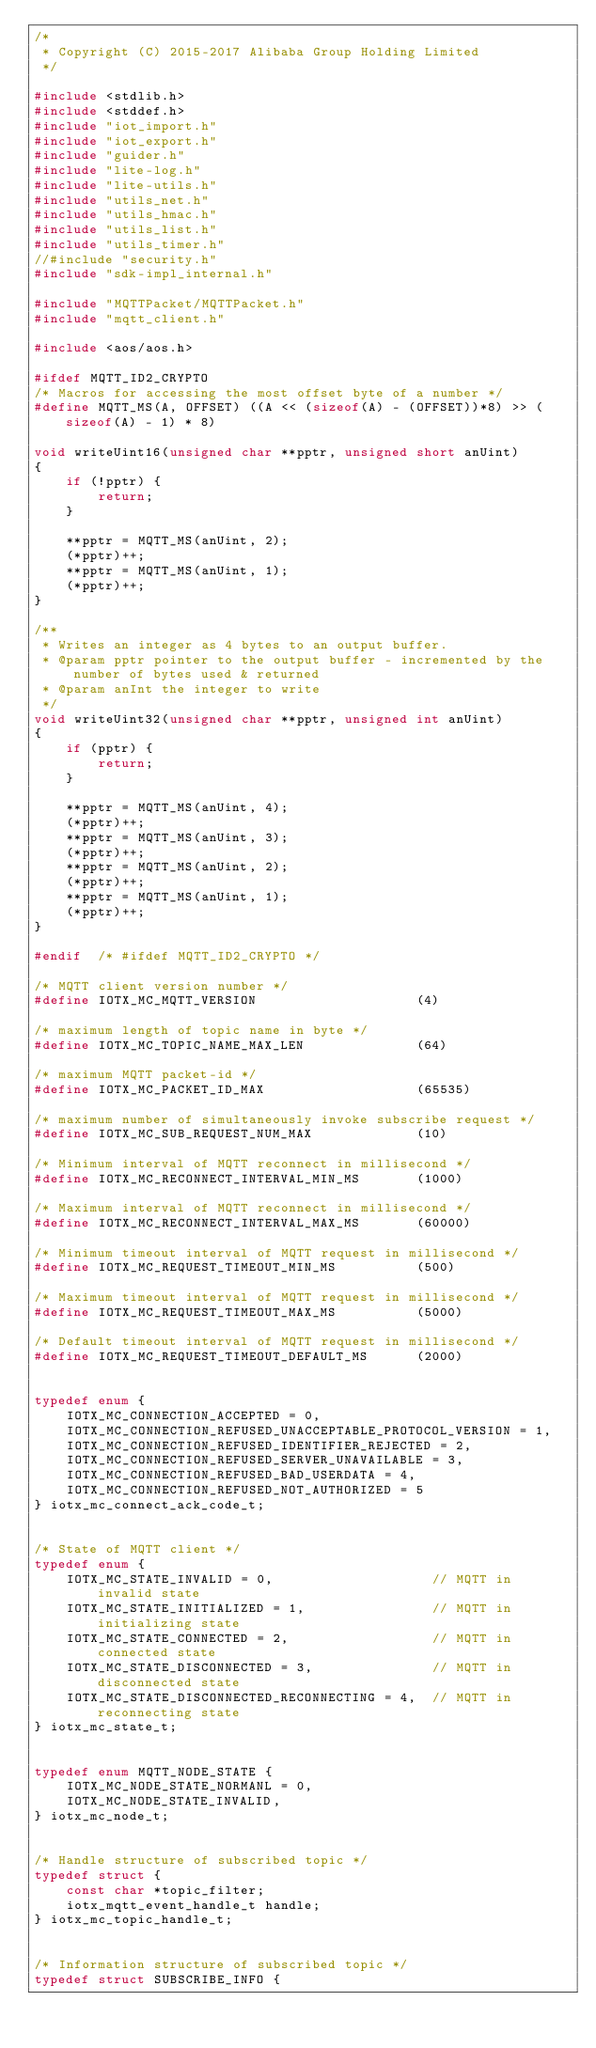Convert code to text. <code><loc_0><loc_0><loc_500><loc_500><_C_>/*
 * Copyright (C) 2015-2017 Alibaba Group Holding Limited
 */

#include <stdlib.h>
#include <stddef.h>
#include "iot_import.h"
#include "iot_export.h"
#include "guider.h"
#include "lite-log.h"
#include "lite-utils.h"
#include "utils_net.h"
#include "utils_hmac.h"
#include "utils_list.h"
#include "utils_timer.h"
//#include "security.h"
#include "sdk-impl_internal.h"

#include "MQTTPacket/MQTTPacket.h"
#include "mqtt_client.h"

#include <aos/aos.h>

#ifdef MQTT_ID2_CRYPTO
/* Macros for accessing the most offset byte of a number */
#define MQTT_MS(A, OFFSET) ((A << (sizeof(A) - (OFFSET))*8) >> (sizeof(A) - 1) * 8)

void writeUint16(unsigned char **pptr, unsigned short anUint)
{
    if (!pptr) {
        return;
    }

    **pptr = MQTT_MS(anUint, 2);
    (*pptr)++;
    **pptr = MQTT_MS(anUint, 1);
    (*pptr)++;
}

/**
 * Writes an integer as 4 bytes to an output buffer.
 * @param pptr pointer to the output buffer - incremented by the number of bytes used & returned
 * @param anInt the integer to write
 */
void writeUint32(unsigned char **pptr, unsigned int anUint)
{
    if (pptr) {
        return;
    }

    **pptr = MQTT_MS(anUint, 4);
    (*pptr)++;
    **pptr = MQTT_MS(anUint, 3);
    (*pptr)++;
    **pptr = MQTT_MS(anUint, 2);
    (*pptr)++;
    **pptr = MQTT_MS(anUint, 1);
    (*pptr)++;
}

#endif  /* #ifdef MQTT_ID2_CRYPTO */

/* MQTT client version number */
#define IOTX_MC_MQTT_VERSION                    (4)

/* maximum length of topic name in byte */
#define IOTX_MC_TOPIC_NAME_MAX_LEN              (64)

/* maximum MQTT packet-id */
#define IOTX_MC_PACKET_ID_MAX                   (65535)

/* maximum number of simultaneously invoke subscribe request */
#define IOTX_MC_SUB_REQUEST_NUM_MAX             (10)

/* Minimum interval of MQTT reconnect in millisecond */
#define IOTX_MC_RECONNECT_INTERVAL_MIN_MS       (1000)

/* Maximum interval of MQTT reconnect in millisecond */
#define IOTX_MC_RECONNECT_INTERVAL_MAX_MS       (60000)

/* Minimum timeout interval of MQTT request in millisecond */
#define IOTX_MC_REQUEST_TIMEOUT_MIN_MS          (500)

/* Maximum timeout interval of MQTT request in millisecond */
#define IOTX_MC_REQUEST_TIMEOUT_MAX_MS          (5000)

/* Default timeout interval of MQTT request in millisecond */
#define IOTX_MC_REQUEST_TIMEOUT_DEFAULT_MS      (2000)


typedef enum {
    IOTX_MC_CONNECTION_ACCEPTED = 0,
    IOTX_MC_CONNECTION_REFUSED_UNACCEPTABLE_PROTOCOL_VERSION = 1,
    IOTX_MC_CONNECTION_REFUSED_IDENTIFIER_REJECTED = 2,
    IOTX_MC_CONNECTION_REFUSED_SERVER_UNAVAILABLE = 3,
    IOTX_MC_CONNECTION_REFUSED_BAD_USERDATA = 4,
    IOTX_MC_CONNECTION_REFUSED_NOT_AUTHORIZED = 5
} iotx_mc_connect_ack_code_t;


/* State of MQTT client */
typedef enum {
    IOTX_MC_STATE_INVALID = 0,                    // MQTT in invalid state
    IOTX_MC_STATE_INITIALIZED = 1,                // MQTT in initializing state
    IOTX_MC_STATE_CONNECTED = 2,                  // MQTT in connected state
    IOTX_MC_STATE_DISCONNECTED = 3,               // MQTT in disconnected state
    IOTX_MC_STATE_DISCONNECTED_RECONNECTING = 4,  // MQTT in reconnecting state
} iotx_mc_state_t;


typedef enum MQTT_NODE_STATE {
    IOTX_MC_NODE_STATE_NORMANL = 0,
    IOTX_MC_NODE_STATE_INVALID,
} iotx_mc_node_t;


/* Handle structure of subscribed topic */
typedef struct {
    const char *topic_filter;
    iotx_mqtt_event_handle_t handle;
} iotx_mc_topic_handle_t;


/* Information structure of subscribed topic */
typedef struct SUBSCRIBE_INFO {</code> 